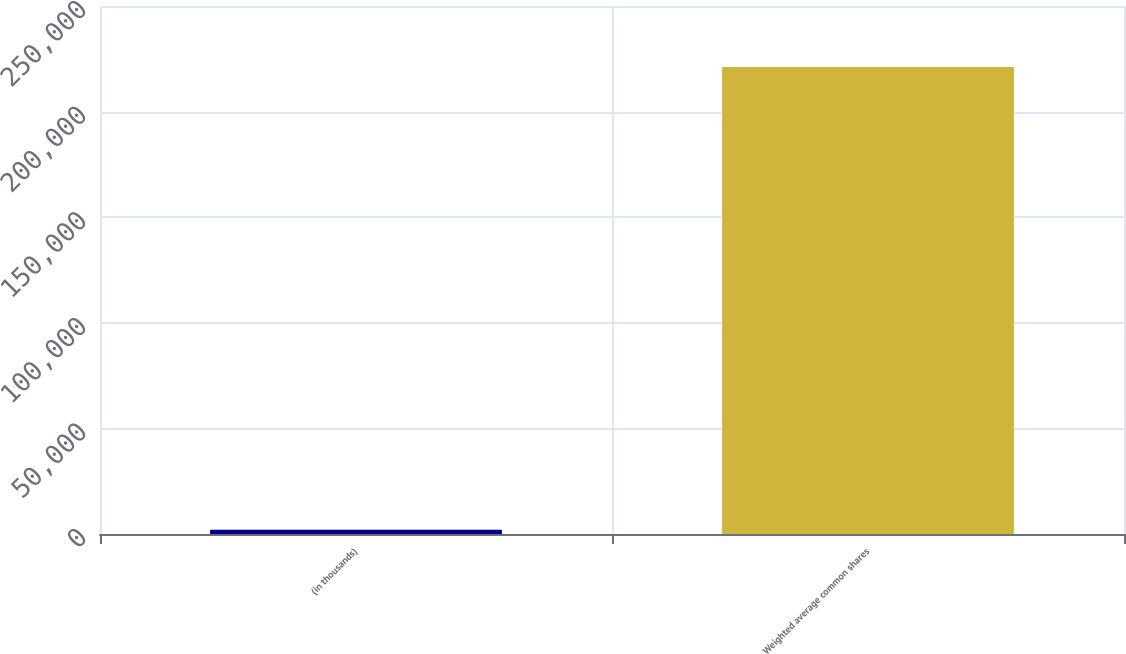Convert chart. <chart><loc_0><loc_0><loc_500><loc_500><bar_chart><fcel>(in thousands)<fcel>Weighted average common shares<nl><fcel>2009<fcel>221082<nl></chart> 